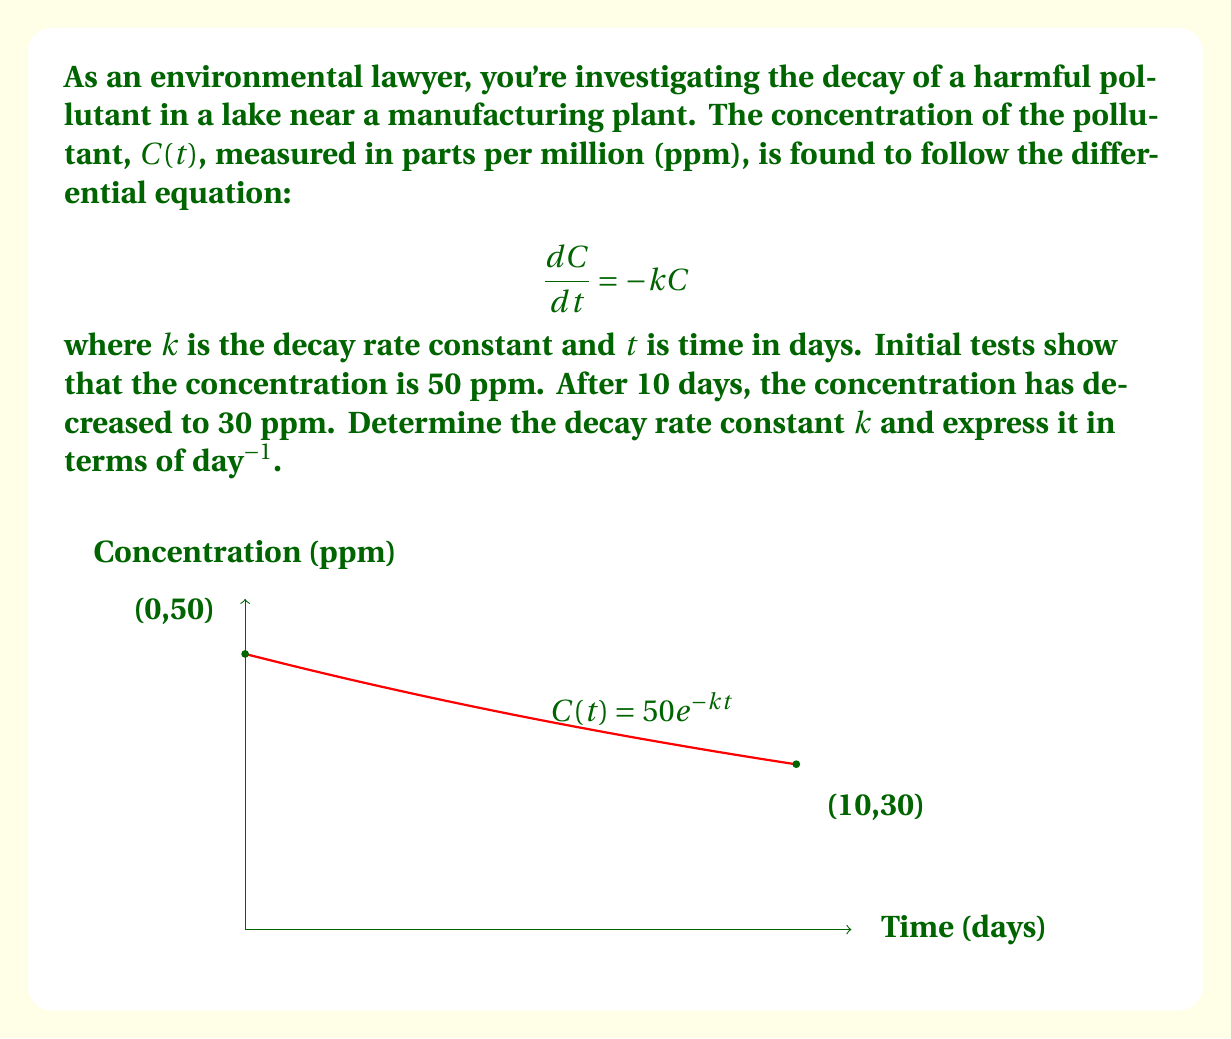What is the answer to this math problem? Let's solve this step-by-step:

1) The general solution to the differential equation $\frac{dC}{dt} = -kC$ is:

   $$C(t) = C_0e^{-kt}$$

   where $C_0$ is the initial concentration.

2) We're given that $C_0 = 50$ ppm and after 10 days, $C(10) = 30$ ppm. Let's substitute these into our equation:

   $$30 = 50e^{-k(10)}$$

3) Dividing both sides by 50:

   $$\frac{3}{5} = e^{-10k}$$

4) Taking the natural logarithm of both sides:

   $$\ln(\frac{3}{5}) = -10k$$

5) Solving for $k$:

   $$k = -\frac{1}{10}\ln(\frac{3}{5})$$

6) Calculate this value:

   $$k = -\frac{1}{10}(-0.5108) \approx 0.0511$$

7) The units of $k$ are day⁻¹, as time $t$ is measured in days.
Answer: $k \approx 0.0511$ day⁻¹ 